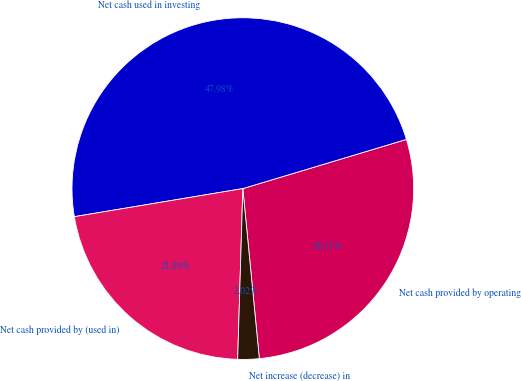<chart> <loc_0><loc_0><loc_500><loc_500><pie_chart><fcel>Net cash provided by operating<fcel>Net cash used in investing<fcel>Net cash provided by (used in)<fcel>Net increase (decrease) in<nl><fcel>28.11%<fcel>47.98%<fcel>21.89%<fcel>2.02%<nl></chart> 